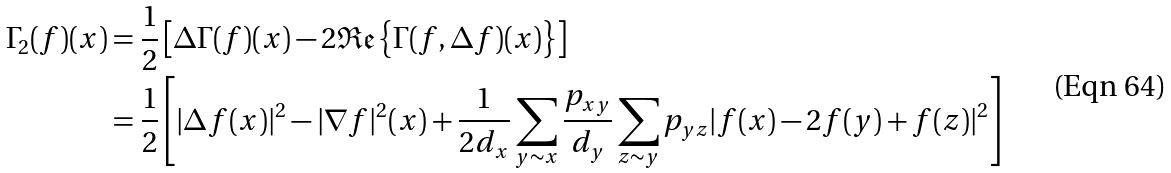<formula> <loc_0><loc_0><loc_500><loc_500>\Gamma _ { 2 } ( f ) ( x ) & = \frac { 1 } { 2 } \left [ \Delta \Gamma ( f ) ( x ) - 2 \mathfrak { R e } \left \{ \Gamma ( f , \Delta f ) ( x ) \right \} \right ] \\ & = \frac { 1 } { 2 } \left [ | \Delta f ( x ) | ^ { 2 } - | \nabla f | ^ { 2 } ( x ) + \frac { 1 } { 2 d _ { x } } \sum _ { y \sim x } \frac { p _ { x y } } { d _ { y } } \sum _ { z \sim y } p _ { y z } | f ( x ) - 2 f ( y ) + f ( z ) | ^ { 2 } \right ]</formula> 